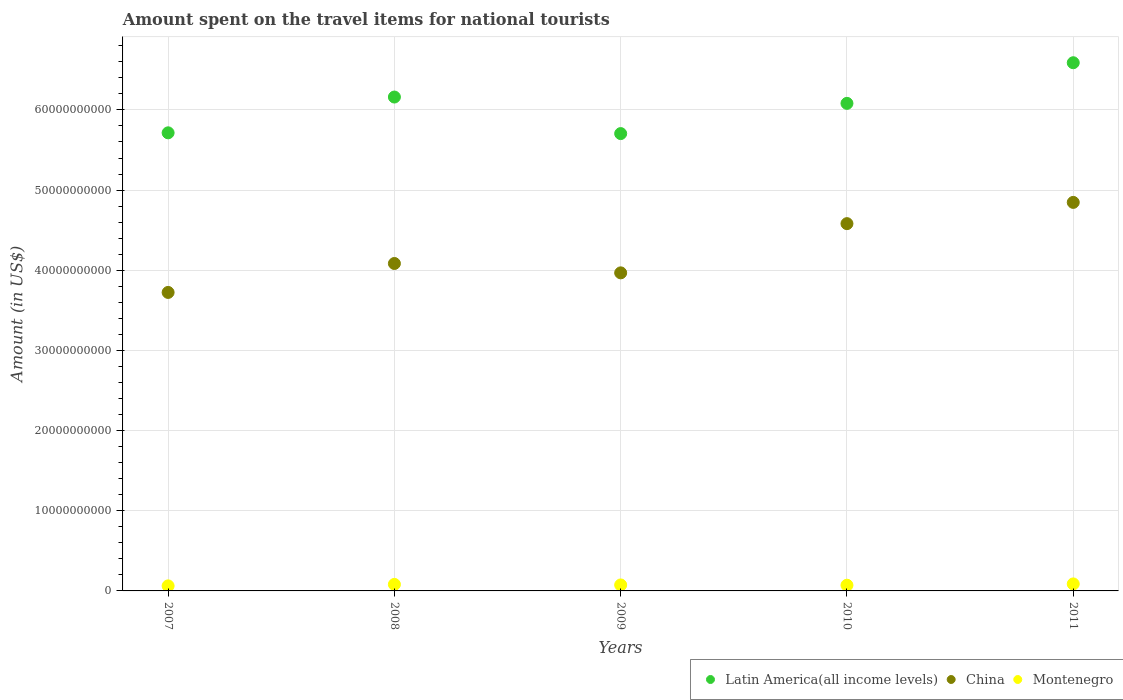How many different coloured dotlines are there?
Provide a succinct answer. 3. Is the number of dotlines equal to the number of legend labels?
Provide a short and direct response. Yes. What is the amount spent on the travel items for national tourists in Montenegro in 2009?
Provide a succinct answer. 7.45e+08. Across all years, what is the maximum amount spent on the travel items for national tourists in Latin America(all income levels)?
Keep it short and to the point. 6.59e+1. Across all years, what is the minimum amount spent on the travel items for national tourists in Latin America(all income levels)?
Ensure brevity in your answer.  5.70e+1. In which year was the amount spent on the travel items for national tourists in China maximum?
Make the answer very short. 2011. What is the total amount spent on the travel items for national tourists in China in the graph?
Offer a terse response. 2.12e+11. What is the difference between the amount spent on the travel items for national tourists in China in 2008 and that in 2011?
Ensure brevity in your answer.  -7.62e+09. What is the difference between the amount spent on the travel items for national tourists in China in 2011 and the amount spent on the travel items for national tourists in Latin America(all income levels) in 2007?
Your answer should be compact. -8.68e+09. What is the average amount spent on the travel items for national tourists in Latin America(all income levels) per year?
Your answer should be compact. 6.05e+1. In the year 2009, what is the difference between the amount spent on the travel items for national tourists in Montenegro and amount spent on the travel items for national tourists in Latin America(all income levels)?
Provide a succinct answer. -5.63e+1. In how many years, is the amount spent on the travel items for national tourists in Latin America(all income levels) greater than 20000000000 US$?
Offer a very short reply. 5. What is the ratio of the amount spent on the travel items for national tourists in Latin America(all income levels) in 2008 to that in 2011?
Give a very brief answer. 0.94. Is the amount spent on the travel items for national tourists in Montenegro in 2010 less than that in 2011?
Provide a succinct answer. Yes. Is the difference between the amount spent on the travel items for national tourists in Montenegro in 2008 and 2009 greater than the difference between the amount spent on the travel items for national tourists in Latin America(all income levels) in 2008 and 2009?
Provide a succinct answer. No. What is the difference between the highest and the second highest amount spent on the travel items for national tourists in Montenegro?
Your answer should be compact. 6.20e+07. What is the difference between the highest and the lowest amount spent on the travel items for national tourists in Montenegro?
Provide a succinct answer. 2.45e+08. In how many years, is the amount spent on the travel items for national tourists in Montenegro greater than the average amount spent on the travel items for national tourists in Montenegro taken over all years?
Provide a succinct answer. 2. Is the sum of the amount spent on the travel items for national tourists in Latin America(all income levels) in 2007 and 2011 greater than the maximum amount spent on the travel items for national tourists in Montenegro across all years?
Ensure brevity in your answer.  Yes. How many dotlines are there?
Offer a very short reply. 3. How many years are there in the graph?
Offer a terse response. 5. What is the difference between two consecutive major ticks on the Y-axis?
Your response must be concise. 1.00e+1. Does the graph contain any zero values?
Your response must be concise. No. Where does the legend appear in the graph?
Your response must be concise. Bottom right. How are the legend labels stacked?
Your response must be concise. Horizontal. What is the title of the graph?
Offer a terse response. Amount spent on the travel items for national tourists. What is the label or title of the Y-axis?
Offer a very short reply. Amount (in US$). What is the Amount (in US$) of Latin America(all income levels) in 2007?
Offer a very short reply. 5.71e+1. What is the Amount (in US$) of China in 2007?
Provide a short and direct response. 3.72e+1. What is the Amount (in US$) of Montenegro in 2007?
Ensure brevity in your answer.  6.30e+08. What is the Amount (in US$) of Latin America(all income levels) in 2008?
Your answer should be very brief. 6.16e+1. What is the Amount (in US$) in China in 2008?
Provide a succinct answer. 4.08e+1. What is the Amount (in US$) of Montenegro in 2008?
Keep it short and to the point. 8.13e+08. What is the Amount (in US$) in Latin America(all income levels) in 2009?
Your answer should be very brief. 5.70e+1. What is the Amount (in US$) in China in 2009?
Ensure brevity in your answer.  3.97e+1. What is the Amount (in US$) of Montenegro in 2009?
Your answer should be compact. 7.45e+08. What is the Amount (in US$) in Latin America(all income levels) in 2010?
Give a very brief answer. 6.08e+1. What is the Amount (in US$) in China in 2010?
Provide a succinct answer. 4.58e+1. What is the Amount (in US$) in Montenegro in 2010?
Your response must be concise. 7.13e+08. What is the Amount (in US$) in Latin America(all income levels) in 2011?
Make the answer very short. 6.59e+1. What is the Amount (in US$) in China in 2011?
Make the answer very short. 4.85e+1. What is the Amount (in US$) of Montenegro in 2011?
Ensure brevity in your answer.  8.75e+08. Across all years, what is the maximum Amount (in US$) of Latin America(all income levels)?
Provide a succinct answer. 6.59e+1. Across all years, what is the maximum Amount (in US$) of China?
Your answer should be compact. 4.85e+1. Across all years, what is the maximum Amount (in US$) of Montenegro?
Offer a terse response. 8.75e+08. Across all years, what is the minimum Amount (in US$) in Latin America(all income levels)?
Ensure brevity in your answer.  5.70e+1. Across all years, what is the minimum Amount (in US$) of China?
Your answer should be compact. 3.72e+1. Across all years, what is the minimum Amount (in US$) of Montenegro?
Your answer should be compact. 6.30e+08. What is the total Amount (in US$) of Latin America(all income levels) in the graph?
Ensure brevity in your answer.  3.02e+11. What is the total Amount (in US$) of China in the graph?
Give a very brief answer. 2.12e+11. What is the total Amount (in US$) of Montenegro in the graph?
Keep it short and to the point. 3.78e+09. What is the difference between the Amount (in US$) of Latin America(all income levels) in 2007 and that in 2008?
Provide a succinct answer. -4.46e+09. What is the difference between the Amount (in US$) of China in 2007 and that in 2008?
Offer a terse response. -3.61e+09. What is the difference between the Amount (in US$) of Montenegro in 2007 and that in 2008?
Make the answer very short. -1.83e+08. What is the difference between the Amount (in US$) in Latin America(all income levels) in 2007 and that in 2009?
Give a very brief answer. 9.54e+07. What is the difference between the Amount (in US$) in China in 2007 and that in 2009?
Keep it short and to the point. -2.44e+09. What is the difference between the Amount (in US$) of Montenegro in 2007 and that in 2009?
Offer a terse response. -1.15e+08. What is the difference between the Amount (in US$) in Latin America(all income levels) in 2007 and that in 2010?
Your answer should be very brief. -3.67e+09. What is the difference between the Amount (in US$) in China in 2007 and that in 2010?
Your answer should be compact. -8.58e+09. What is the difference between the Amount (in US$) in Montenegro in 2007 and that in 2010?
Provide a succinct answer. -8.30e+07. What is the difference between the Amount (in US$) in Latin America(all income levels) in 2007 and that in 2011?
Your answer should be very brief. -8.74e+09. What is the difference between the Amount (in US$) of China in 2007 and that in 2011?
Your response must be concise. -1.12e+1. What is the difference between the Amount (in US$) of Montenegro in 2007 and that in 2011?
Give a very brief answer. -2.45e+08. What is the difference between the Amount (in US$) of Latin America(all income levels) in 2008 and that in 2009?
Ensure brevity in your answer.  4.56e+09. What is the difference between the Amount (in US$) of China in 2008 and that in 2009?
Make the answer very short. 1.17e+09. What is the difference between the Amount (in US$) in Montenegro in 2008 and that in 2009?
Make the answer very short. 6.80e+07. What is the difference between the Amount (in US$) in Latin America(all income levels) in 2008 and that in 2010?
Provide a short and direct response. 7.90e+08. What is the difference between the Amount (in US$) in China in 2008 and that in 2010?
Keep it short and to the point. -4.97e+09. What is the difference between the Amount (in US$) in Latin America(all income levels) in 2008 and that in 2011?
Ensure brevity in your answer.  -4.28e+09. What is the difference between the Amount (in US$) of China in 2008 and that in 2011?
Your answer should be compact. -7.62e+09. What is the difference between the Amount (in US$) of Montenegro in 2008 and that in 2011?
Keep it short and to the point. -6.20e+07. What is the difference between the Amount (in US$) in Latin America(all income levels) in 2009 and that in 2010?
Provide a short and direct response. -3.77e+09. What is the difference between the Amount (in US$) in China in 2009 and that in 2010?
Offer a very short reply. -6.14e+09. What is the difference between the Amount (in US$) in Montenegro in 2009 and that in 2010?
Your response must be concise. 3.20e+07. What is the difference between the Amount (in US$) in Latin America(all income levels) in 2009 and that in 2011?
Provide a short and direct response. -8.84e+09. What is the difference between the Amount (in US$) in China in 2009 and that in 2011?
Provide a short and direct response. -8.79e+09. What is the difference between the Amount (in US$) of Montenegro in 2009 and that in 2011?
Provide a short and direct response. -1.30e+08. What is the difference between the Amount (in US$) in Latin America(all income levels) in 2010 and that in 2011?
Your answer should be very brief. -5.07e+09. What is the difference between the Amount (in US$) of China in 2010 and that in 2011?
Keep it short and to the point. -2.65e+09. What is the difference between the Amount (in US$) in Montenegro in 2010 and that in 2011?
Your answer should be compact. -1.62e+08. What is the difference between the Amount (in US$) of Latin America(all income levels) in 2007 and the Amount (in US$) of China in 2008?
Provide a short and direct response. 1.63e+1. What is the difference between the Amount (in US$) in Latin America(all income levels) in 2007 and the Amount (in US$) in Montenegro in 2008?
Ensure brevity in your answer.  5.63e+1. What is the difference between the Amount (in US$) in China in 2007 and the Amount (in US$) in Montenegro in 2008?
Make the answer very short. 3.64e+1. What is the difference between the Amount (in US$) in Latin America(all income levels) in 2007 and the Amount (in US$) in China in 2009?
Offer a very short reply. 1.75e+1. What is the difference between the Amount (in US$) in Latin America(all income levels) in 2007 and the Amount (in US$) in Montenegro in 2009?
Your answer should be compact. 5.64e+1. What is the difference between the Amount (in US$) in China in 2007 and the Amount (in US$) in Montenegro in 2009?
Offer a terse response. 3.65e+1. What is the difference between the Amount (in US$) of Latin America(all income levels) in 2007 and the Amount (in US$) of China in 2010?
Offer a terse response. 1.13e+1. What is the difference between the Amount (in US$) of Latin America(all income levels) in 2007 and the Amount (in US$) of Montenegro in 2010?
Offer a terse response. 5.64e+1. What is the difference between the Amount (in US$) of China in 2007 and the Amount (in US$) of Montenegro in 2010?
Offer a very short reply. 3.65e+1. What is the difference between the Amount (in US$) in Latin America(all income levels) in 2007 and the Amount (in US$) in China in 2011?
Your answer should be compact. 8.68e+09. What is the difference between the Amount (in US$) of Latin America(all income levels) in 2007 and the Amount (in US$) of Montenegro in 2011?
Your answer should be compact. 5.63e+1. What is the difference between the Amount (in US$) of China in 2007 and the Amount (in US$) of Montenegro in 2011?
Offer a terse response. 3.64e+1. What is the difference between the Amount (in US$) in Latin America(all income levels) in 2008 and the Amount (in US$) in China in 2009?
Your answer should be very brief. 2.19e+1. What is the difference between the Amount (in US$) of Latin America(all income levels) in 2008 and the Amount (in US$) of Montenegro in 2009?
Provide a succinct answer. 6.09e+1. What is the difference between the Amount (in US$) in China in 2008 and the Amount (in US$) in Montenegro in 2009?
Offer a terse response. 4.01e+1. What is the difference between the Amount (in US$) in Latin America(all income levels) in 2008 and the Amount (in US$) in China in 2010?
Your answer should be very brief. 1.58e+1. What is the difference between the Amount (in US$) of Latin America(all income levels) in 2008 and the Amount (in US$) of Montenegro in 2010?
Keep it short and to the point. 6.09e+1. What is the difference between the Amount (in US$) in China in 2008 and the Amount (in US$) in Montenegro in 2010?
Your response must be concise. 4.01e+1. What is the difference between the Amount (in US$) in Latin America(all income levels) in 2008 and the Amount (in US$) in China in 2011?
Your answer should be very brief. 1.31e+1. What is the difference between the Amount (in US$) in Latin America(all income levels) in 2008 and the Amount (in US$) in Montenegro in 2011?
Offer a terse response. 6.07e+1. What is the difference between the Amount (in US$) of China in 2008 and the Amount (in US$) of Montenegro in 2011?
Offer a very short reply. 4.00e+1. What is the difference between the Amount (in US$) in Latin America(all income levels) in 2009 and the Amount (in US$) in China in 2010?
Your answer should be compact. 1.12e+1. What is the difference between the Amount (in US$) of Latin America(all income levels) in 2009 and the Amount (in US$) of Montenegro in 2010?
Your answer should be compact. 5.63e+1. What is the difference between the Amount (in US$) in China in 2009 and the Amount (in US$) in Montenegro in 2010?
Ensure brevity in your answer.  3.90e+1. What is the difference between the Amount (in US$) of Latin America(all income levels) in 2009 and the Amount (in US$) of China in 2011?
Provide a short and direct response. 8.58e+09. What is the difference between the Amount (in US$) of Latin America(all income levels) in 2009 and the Amount (in US$) of Montenegro in 2011?
Ensure brevity in your answer.  5.62e+1. What is the difference between the Amount (in US$) of China in 2009 and the Amount (in US$) of Montenegro in 2011?
Make the answer very short. 3.88e+1. What is the difference between the Amount (in US$) of Latin America(all income levels) in 2010 and the Amount (in US$) of China in 2011?
Keep it short and to the point. 1.24e+1. What is the difference between the Amount (in US$) in Latin America(all income levels) in 2010 and the Amount (in US$) in Montenegro in 2011?
Your answer should be very brief. 5.99e+1. What is the difference between the Amount (in US$) of China in 2010 and the Amount (in US$) of Montenegro in 2011?
Offer a very short reply. 4.49e+1. What is the average Amount (in US$) in Latin America(all income levels) per year?
Keep it short and to the point. 6.05e+1. What is the average Amount (in US$) of China per year?
Make the answer very short. 4.24e+1. What is the average Amount (in US$) of Montenegro per year?
Keep it short and to the point. 7.55e+08. In the year 2007, what is the difference between the Amount (in US$) of Latin America(all income levels) and Amount (in US$) of China?
Offer a very short reply. 1.99e+1. In the year 2007, what is the difference between the Amount (in US$) of Latin America(all income levels) and Amount (in US$) of Montenegro?
Keep it short and to the point. 5.65e+1. In the year 2007, what is the difference between the Amount (in US$) in China and Amount (in US$) in Montenegro?
Make the answer very short. 3.66e+1. In the year 2008, what is the difference between the Amount (in US$) in Latin America(all income levels) and Amount (in US$) in China?
Offer a terse response. 2.08e+1. In the year 2008, what is the difference between the Amount (in US$) of Latin America(all income levels) and Amount (in US$) of Montenegro?
Keep it short and to the point. 6.08e+1. In the year 2008, what is the difference between the Amount (in US$) in China and Amount (in US$) in Montenegro?
Provide a short and direct response. 4.00e+1. In the year 2009, what is the difference between the Amount (in US$) of Latin America(all income levels) and Amount (in US$) of China?
Your answer should be very brief. 1.74e+1. In the year 2009, what is the difference between the Amount (in US$) of Latin America(all income levels) and Amount (in US$) of Montenegro?
Ensure brevity in your answer.  5.63e+1. In the year 2009, what is the difference between the Amount (in US$) of China and Amount (in US$) of Montenegro?
Your response must be concise. 3.89e+1. In the year 2010, what is the difference between the Amount (in US$) in Latin America(all income levels) and Amount (in US$) in China?
Offer a very short reply. 1.50e+1. In the year 2010, what is the difference between the Amount (in US$) in Latin America(all income levels) and Amount (in US$) in Montenegro?
Offer a terse response. 6.01e+1. In the year 2010, what is the difference between the Amount (in US$) in China and Amount (in US$) in Montenegro?
Provide a short and direct response. 4.51e+1. In the year 2011, what is the difference between the Amount (in US$) of Latin America(all income levels) and Amount (in US$) of China?
Offer a very short reply. 1.74e+1. In the year 2011, what is the difference between the Amount (in US$) of Latin America(all income levels) and Amount (in US$) of Montenegro?
Provide a succinct answer. 6.50e+1. In the year 2011, what is the difference between the Amount (in US$) in China and Amount (in US$) in Montenegro?
Provide a succinct answer. 4.76e+1. What is the ratio of the Amount (in US$) of Latin America(all income levels) in 2007 to that in 2008?
Your response must be concise. 0.93. What is the ratio of the Amount (in US$) of China in 2007 to that in 2008?
Give a very brief answer. 0.91. What is the ratio of the Amount (in US$) in Montenegro in 2007 to that in 2008?
Give a very brief answer. 0.77. What is the ratio of the Amount (in US$) of Latin America(all income levels) in 2007 to that in 2009?
Provide a short and direct response. 1. What is the ratio of the Amount (in US$) of China in 2007 to that in 2009?
Your answer should be very brief. 0.94. What is the ratio of the Amount (in US$) of Montenegro in 2007 to that in 2009?
Keep it short and to the point. 0.85. What is the ratio of the Amount (in US$) of Latin America(all income levels) in 2007 to that in 2010?
Your response must be concise. 0.94. What is the ratio of the Amount (in US$) in China in 2007 to that in 2010?
Keep it short and to the point. 0.81. What is the ratio of the Amount (in US$) in Montenegro in 2007 to that in 2010?
Ensure brevity in your answer.  0.88. What is the ratio of the Amount (in US$) in Latin America(all income levels) in 2007 to that in 2011?
Your answer should be compact. 0.87. What is the ratio of the Amount (in US$) in China in 2007 to that in 2011?
Keep it short and to the point. 0.77. What is the ratio of the Amount (in US$) in Montenegro in 2007 to that in 2011?
Your response must be concise. 0.72. What is the ratio of the Amount (in US$) of Latin America(all income levels) in 2008 to that in 2009?
Ensure brevity in your answer.  1.08. What is the ratio of the Amount (in US$) of China in 2008 to that in 2009?
Offer a terse response. 1.03. What is the ratio of the Amount (in US$) of Montenegro in 2008 to that in 2009?
Your response must be concise. 1.09. What is the ratio of the Amount (in US$) in Latin America(all income levels) in 2008 to that in 2010?
Make the answer very short. 1.01. What is the ratio of the Amount (in US$) of China in 2008 to that in 2010?
Give a very brief answer. 0.89. What is the ratio of the Amount (in US$) of Montenegro in 2008 to that in 2010?
Ensure brevity in your answer.  1.14. What is the ratio of the Amount (in US$) in Latin America(all income levels) in 2008 to that in 2011?
Your answer should be very brief. 0.94. What is the ratio of the Amount (in US$) in China in 2008 to that in 2011?
Provide a succinct answer. 0.84. What is the ratio of the Amount (in US$) in Montenegro in 2008 to that in 2011?
Your answer should be compact. 0.93. What is the ratio of the Amount (in US$) in Latin America(all income levels) in 2009 to that in 2010?
Your response must be concise. 0.94. What is the ratio of the Amount (in US$) in China in 2009 to that in 2010?
Give a very brief answer. 0.87. What is the ratio of the Amount (in US$) in Montenegro in 2009 to that in 2010?
Your answer should be compact. 1.04. What is the ratio of the Amount (in US$) in Latin America(all income levels) in 2009 to that in 2011?
Your answer should be compact. 0.87. What is the ratio of the Amount (in US$) in China in 2009 to that in 2011?
Offer a terse response. 0.82. What is the ratio of the Amount (in US$) of Montenegro in 2009 to that in 2011?
Provide a short and direct response. 0.85. What is the ratio of the Amount (in US$) in Latin America(all income levels) in 2010 to that in 2011?
Your response must be concise. 0.92. What is the ratio of the Amount (in US$) in China in 2010 to that in 2011?
Provide a short and direct response. 0.95. What is the ratio of the Amount (in US$) in Montenegro in 2010 to that in 2011?
Your response must be concise. 0.81. What is the difference between the highest and the second highest Amount (in US$) in Latin America(all income levels)?
Offer a terse response. 4.28e+09. What is the difference between the highest and the second highest Amount (in US$) of China?
Offer a terse response. 2.65e+09. What is the difference between the highest and the second highest Amount (in US$) in Montenegro?
Give a very brief answer. 6.20e+07. What is the difference between the highest and the lowest Amount (in US$) of Latin America(all income levels)?
Keep it short and to the point. 8.84e+09. What is the difference between the highest and the lowest Amount (in US$) of China?
Ensure brevity in your answer.  1.12e+1. What is the difference between the highest and the lowest Amount (in US$) of Montenegro?
Your answer should be very brief. 2.45e+08. 